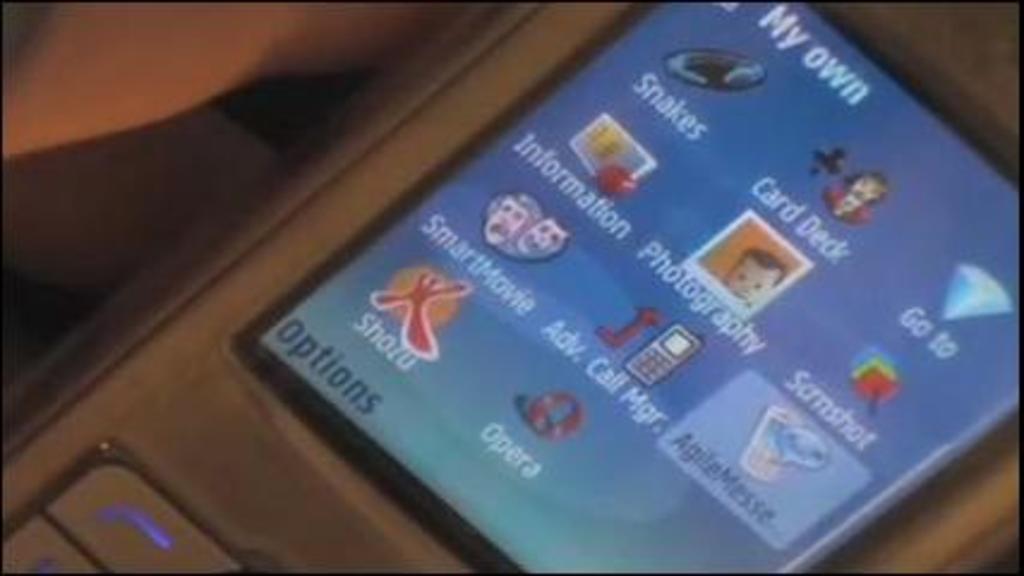What is the word in the bottom left corner?
Your response must be concise. Options. What is word in top left corner?
Offer a very short reply. My. 